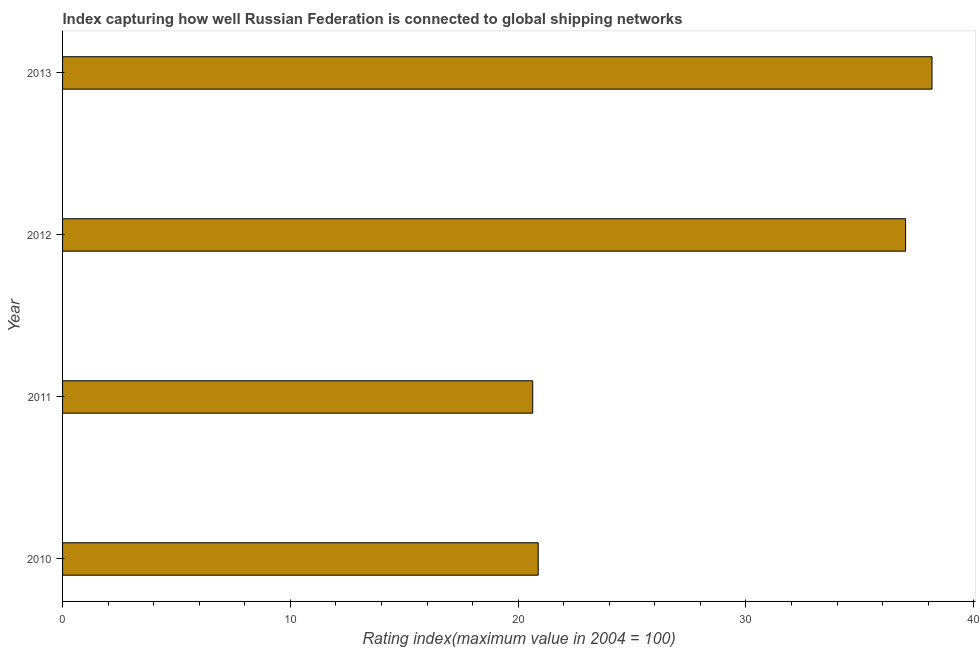Does the graph contain any zero values?
Provide a succinct answer. No. What is the title of the graph?
Your answer should be very brief. Index capturing how well Russian Federation is connected to global shipping networks. What is the label or title of the X-axis?
Offer a very short reply. Rating index(maximum value in 2004 = 100). What is the label or title of the Y-axis?
Your response must be concise. Year. What is the liner shipping connectivity index in 2010?
Offer a very short reply. 20.88. Across all years, what is the maximum liner shipping connectivity index?
Give a very brief answer. 38.17. Across all years, what is the minimum liner shipping connectivity index?
Give a very brief answer. 20.64. In which year was the liner shipping connectivity index maximum?
Offer a very short reply. 2013. What is the sum of the liner shipping connectivity index?
Offer a very short reply. 116.7. What is the difference between the liner shipping connectivity index in 2011 and 2013?
Give a very brief answer. -17.53. What is the average liner shipping connectivity index per year?
Offer a very short reply. 29.18. What is the median liner shipping connectivity index?
Your response must be concise. 28.95. Do a majority of the years between 2010 and 2012 (inclusive) have liner shipping connectivity index greater than 22 ?
Your answer should be compact. No. What is the ratio of the liner shipping connectivity index in 2010 to that in 2011?
Ensure brevity in your answer.  1.01. Is the liner shipping connectivity index in 2010 less than that in 2011?
Your answer should be very brief. No. What is the difference between the highest and the second highest liner shipping connectivity index?
Provide a short and direct response. 1.16. What is the difference between the highest and the lowest liner shipping connectivity index?
Offer a very short reply. 17.53. In how many years, is the liner shipping connectivity index greater than the average liner shipping connectivity index taken over all years?
Give a very brief answer. 2. How many bars are there?
Your response must be concise. 4. Are all the bars in the graph horizontal?
Make the answer very short. Yes. What is the difference between two consecutive major ticks on the X-axis?
Provide a succinct answer. 10. Are the values on the major ticks of X-axis written in scientific E-notation?
Your response must be concise. No. What is the Rating index(maximum value in 2004 = 100) of 2010?
Provide a succinct answer. 20.88. What is the Rating index(maximum value in 2004 = 100) of 2011?
Make the answer very short. 20.64. What is the Rating index(maximum value in 2004 = 100) of 2012?
Give a very brief answer. 37.01. What is the Rating index(maximum value in 2004 = 100) in 2013?
Give a very brief answer. 38.17. What is the difference between the Rating index(maximum value in 2004 = 100) in 2010 and 2011?
Your answer should be very brief. 0.24. What is the difference between the Rating index(maximum value in 2004 = 100) in 2010 and 2012?
Ensure brevity in your answer.  -16.13. What is the difference between the Rating index(maximum value in 2004 = 100) in 2010 and 2013?
Your response must be concise. -17.29. What is the difference between the Rating index(maximum value in 2004 = 100) in 2011 and 2012?
Offer a terse response. -16.37. What is the difference between the Rating index(maximum value in 2004 = 100) in 2011 and 2013?
Your response must be concise. -17.53. What is the difference between the Rating index(maximum value in 2004 = 100) in 2012 and 2013?
Ensure brevity in your answer.  -1.16. What is the ratio of the Rating index(maximum value in 2004 = 100) in 2010 to that in 2012?
Keep it short and to the point. 0.56. What is the ratio of the Rating index(maximum value in 2004 = 100) in 2010 to that in 2013?
Keep it short and to the point. 0.55. What is the ratio of the Rating index(maximum value in 2004 = 100) in 2011 to that in 2012?
Ensure brevity in your answer.  0.56. What is the ratio of the Rating index(maximum value in 2004 = 100) in 2011 to that in 2013?
Make the answer very short. 0.54. 